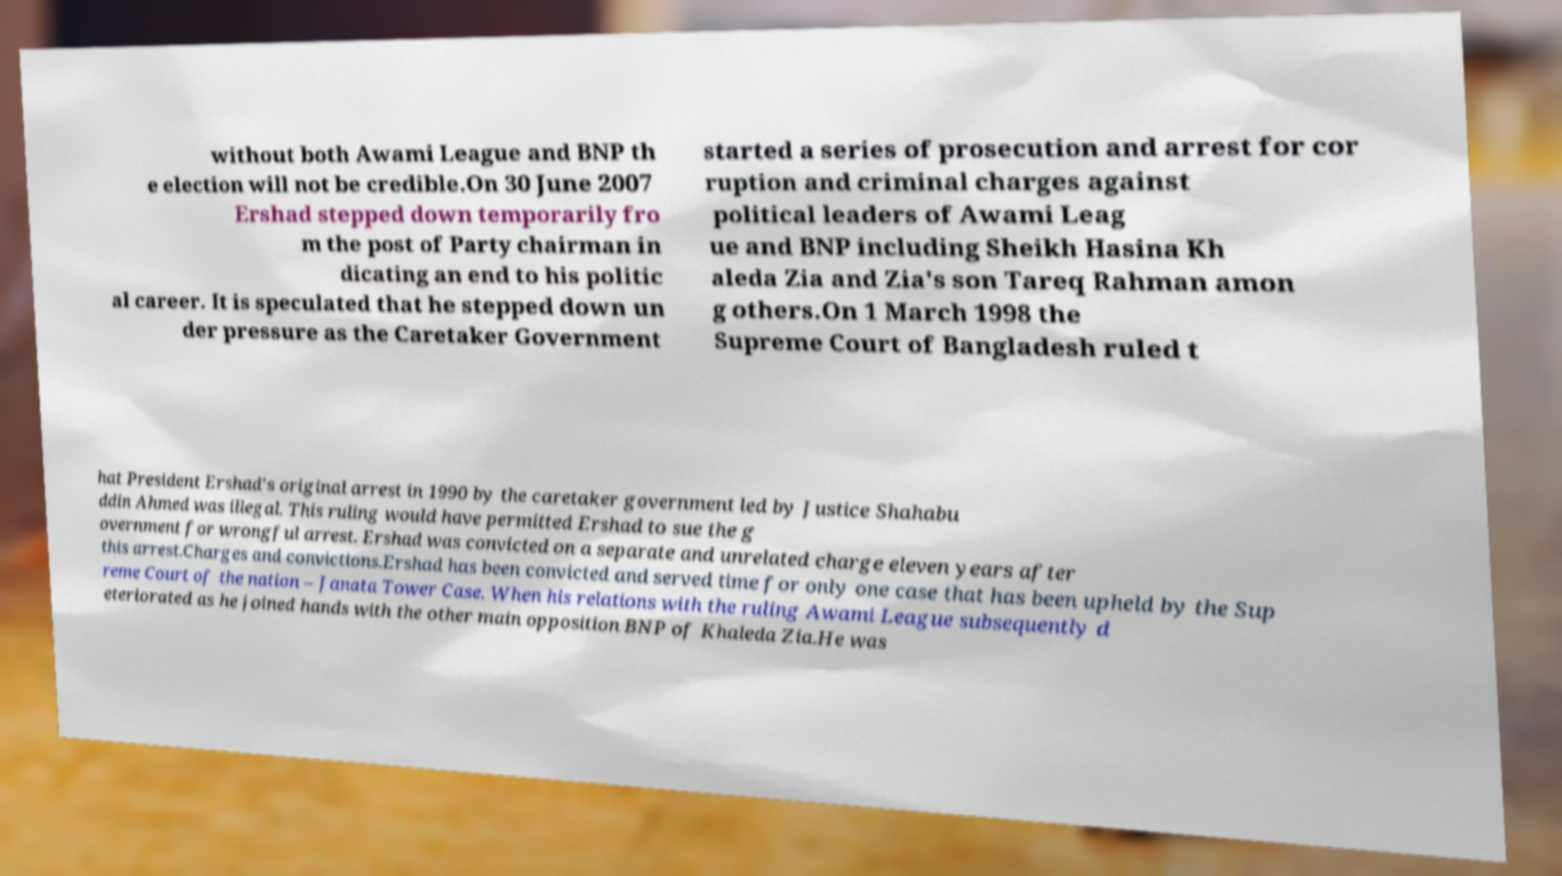Can you accurately transcribe the text from the provided image for me? without both Awami League and BNP th e election will not be credible.On 30 June 2007 Ershad stepped down temporarily fro m the post of Party chairman in dicating an end to his politic al career. It is speculated that he stepped down un der pressure as the Caretaker Government started a series of prosecution and arrest for cor ruption and criminal charges against political leaders of Awami Leag ue and BNP including Sheikh Hasina Kh aleda Zia and Zia's son Tareq Rahman amon g others.On 1 March 1998 the Supreme Court of Bangladesh ruled t hat President Ershad's original arrest in 1990 by the caretaker government led by Justice Shahabu ddin Ahmed was illegal. This ruling would have permitted Ershad to sue the g overnment for wrongful arrest. Ershad was convicted on a separate and unrelated charge eleven years after this arrest.Charges and convictions.Ershad has been convicted and served time for only one case that has been upheld by the Sup reme Court of the nation – Janata Tower Case. When his relations with the ruling Awami League subsequently d eteriorated as he joined hands with the other main opposition BNP of Khaleda Zia.He was 